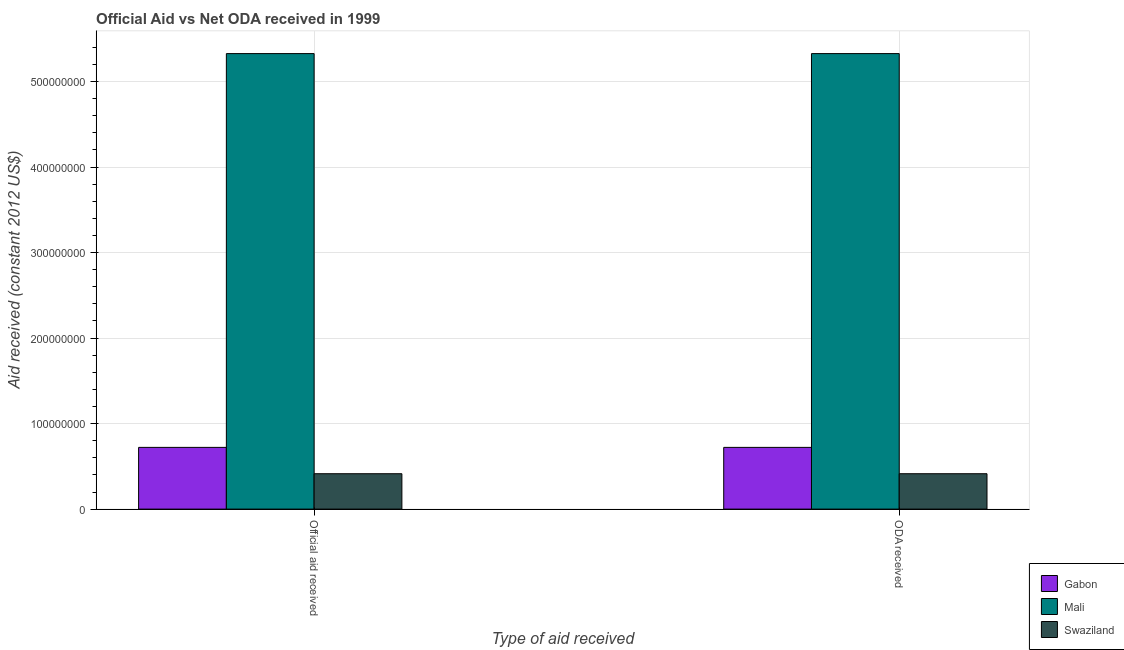How many different coloured bars are there?
Offer a very short reply. 3. How many groups of bars are there?
Ensure brevity in your answer.  2. How many bars are there on the 2nd tick from the left?
Keep it short and to the point. 3. What is the label of the 2nd group of bars from the left?
Make the answer very short. ODA received. What is the oda received in Swaziland?
Your answer should be compact. 4.14e+07. Across all countries, what is the maximum official aid received?
Your answer should be very brief. 5.33e+08. Across all countries, what is the minimum oda received?
Your response must be concise. 4.14e+07. In which country was the oda received maximum?
Your answer should be very brief. Mali. In which country was the official aid received minimum?
Provide a short and direct response. Swaziland. What is the total oda received in the graph?
Keep it short and to the point. 6.46e+08. What is the difference between the oda received in Gabon and that in Swaziland?
Offer a very short reply. 3.08e+07. What is the difference between the oda received in Mali and the official aid received in Gabon?
Offer a terse response. 4.61e+08. What is the average official aid received per country?
Your answer should be compact. 2.15e+08. What is the ratio of the oda received in Gabon to that in Mali?
Your answer should be very brief. 0.14. Is the official aid received in Swaziland less than that in Gabon?
Make the answer very short. Yes. In how many countries, is the official aid received greater than the average official aid received taken over all countries?
Offer a very short reply. 1. What does the 3rd bar from the left in ODA received represents?
Provide a succinct answer. Swaziland. What does the 3rd bar from the right in ODA received represents?
Provide a succinct answer. Gabon. Are all the bars in the graph horizontal?
Keep it short and to the point. No. How many countries are there in the graph?
Keep it short and to the point. 3. Are the values on the major ticks of Y-axis written in scientific E-notation?
Your response must be concise. No. Where does the legend appear in the graph?
Ensure brevity in your answer.  Bottom right. How many legend labels are there?
Your answer should be very brief. 3. How are the legend labels stacked?
Ensure brevity in your answer.  Vertical. What is the title of the graph?
Make the answer very short. Official Aid vs Net ODA received in 1999 . Does "Uzbekistan" appear as one of the legend labels in the graph?
Offer a very short reply. No. What is the label or title of the X-axis?
Your answer should be very brief. Type of aid received. What is the label or title of the Y-axis?
Your answer should be very brief. Aid received (constant 2012 US$). What is the Aid received (constant 2012 US$) in Gabon in Official aid received?
Offer a very short reply. 7.22e+07. What is the Aid received (constant 2012 US$) of Mali in Official aid received?
Offer a very short reply. 5.33e+08. What is the Aid received (constant 2012 US$) of Swaziland in Official aid received?
Give a very brief answer. 4.14e+07. What is the Aid received (constant 2012 US$) in Gabon in ODA received?
Provide a short and direct response. 7.22e+07. What is the Aid received (constant 2012 US$) of Mali in ODA received?
Provide a short and direct response. 5.33e+08. What is the Aid received (constant 2012 US$) of Swaziland in ODA received?
Offer a terse response. 4.14e+07. Across all Type of aid received, what is the maximum Aid received (constant 2012 US$) of Gabon?
Offer a very short reply. 7.22e+07. Across all Type of aid received, what is the maximum Aid received (constant 2012 US$) in Mali?
Your response must be concise. 5.33e+08. Across all Type of aid received, what is the maximum Aid received (constant 2012 US$) of Swaziland?
Your answer should be very brief. 4.14e+07. Across all Type of aid received, what is the minimum Aid received (constant 2012 US$) of Gabon?
Provide a succinct answer. 7.22e+07. Across all Type of aid received, what is the minimum Aid received (constant 2012 US$) in Mali?
Offer a terse response. 5.33e+08. Across all Type of aid received, what is the minimum Aid received (constant 2012 US$) of Swaziland?
Provide a short and direct response. 4.14e+07. What is the total Aid received (constant 2012 US$) in Gabon in the graph?
Your answer should be compact. 1.44e+08. What is the total Aid received (constant 2012 US$) of Mali in the graph?
Keep it short and to the point. 1.07e+09. What is the total Aid received (constant 2012 US$) in Swaziland in the graph?
Your answer should be very brief. 8.27e+07. What is the difference between the Aid received (constant 2012 US$) of Swaziland in Official aid received and that in ODA received?
Make the answer very short. 0. What is the difference between the Aid received (constant 2012 US$) of Gabon in Official aid received and the Aid received (constant 2012 US$) of Mali in ODA received?
Your response must be concise. -4.61e+08. What is the difference between the Aid received (constant 2012 US$) of Gabon in Official aid received and the Aid received (constant 2012 US$) of Swaziland in ODA received?
Give a very brief answer. 3.08e+07. What is the difference between the Aid received (constant 2012 US$) in Mali in Official aid received and the Aid received (constant 2012 US$) in Swaziland in ODA received?
Your answer should be compact. 4.91e+08. What is the average Aid received (constant 2012 US$) in Gabon per Type of aid received?
Offer a terse response. 7.22e+07. What is the average Aid received (constant 2012 US$) in Mali per Type of aid received?
Offer a very short reply. 5.33e+08. What is the average Aid received (constant 2012 US$) of Swaziland per Type of aid received?
Give a very brief answer. 4.14e+07. What is the difference between the Aid received (constant 2012 US$) of Gabon and Aid received (constant 2012 US$) of Mali in Official aid received?
Your answer should be very brief. -4.61e+08. What is the difference between the Aid received (constant 2012 US$) in Gabon and Aid received (constant 2012 US$) in Swaziland in Official aid received?
Your answer should be compact. 3.08e+07. What is the difference between the Aid received (constant 2012 US$) in Mali and Aid received (constant 2012 US$) in Swaziland in Official aid received?
Offer a terse response. 4.91e+08. What is the difference between the Aid received (constant 2012 US$) in Gabon and Aid received (constant 2012 US$) in Mali in ODA received?
Your answer should be very brief. -4.61e+08. What is the difference between the Aid received (constant 2012 US$) in Gabon and Aid received (constant 2012 US$) in Swaziland in ODA received?
Provide a succinct answer. 3.08e+07. What is the difference between the Aid received (constant 2012 US$) of Mali and Aid received (constant 2012 US$) of Swaziland in ODA received?
Offer a very short reply. 4.91e+08. What is the ratio of the Aid received (constant 2012 US$) of Swaziland in Official aid received to that in ODA received?
Provide a succinct answer. 1. What is the difference between the highest and the second highest Aid received (constant 2012 US$) in Gabon?
Provide a succinct answer. 0. What is the difference between the highest and the second highest Aid received (constant 2012 US$) in Mali?
Give a very brief answer. 0. What is the difference between the highest and the second highest Aid received (constant 2012 US$) of Swaziland?
Offer a terse response. 0. What is the difference between the highest and the lowest Aid received (constant 2012 US$) of Gabon?
Keep it short and to the point. 0. What is the difference between the highest and the lowest Aid received (constant 2012 US$) in Mali?
Provide a short and direct response. 0. What is the difference between the highest and the lowest Aid received (constant 2012 US$) of Swaziland?
Make the answer very short. 0. 